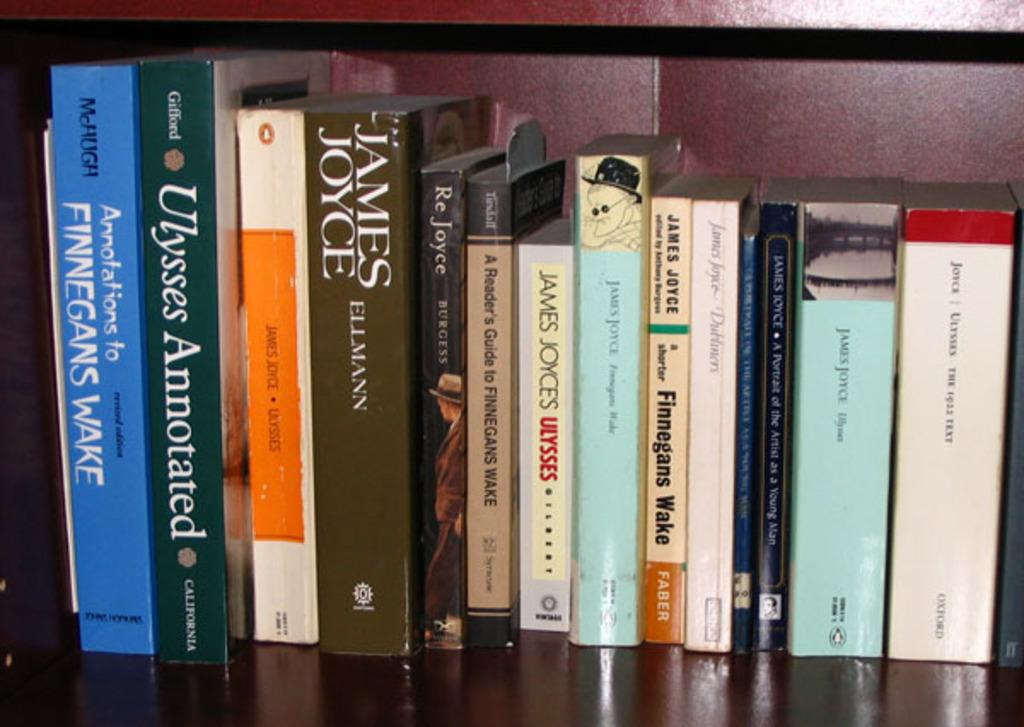<image>
Summarize the visual content of the image. A group of books which are of different size, with more than one being by somebody with the surname Joyce. 